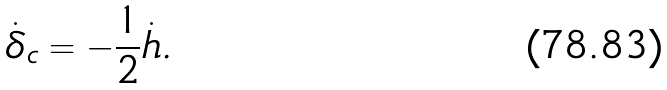Convert formula to latex. <formula><loc_0><loc_0><loc_500><loc_500>\dot { \delta } _ { c } = - \frac { 1 } { 2 } \dot { h } .</formula> 